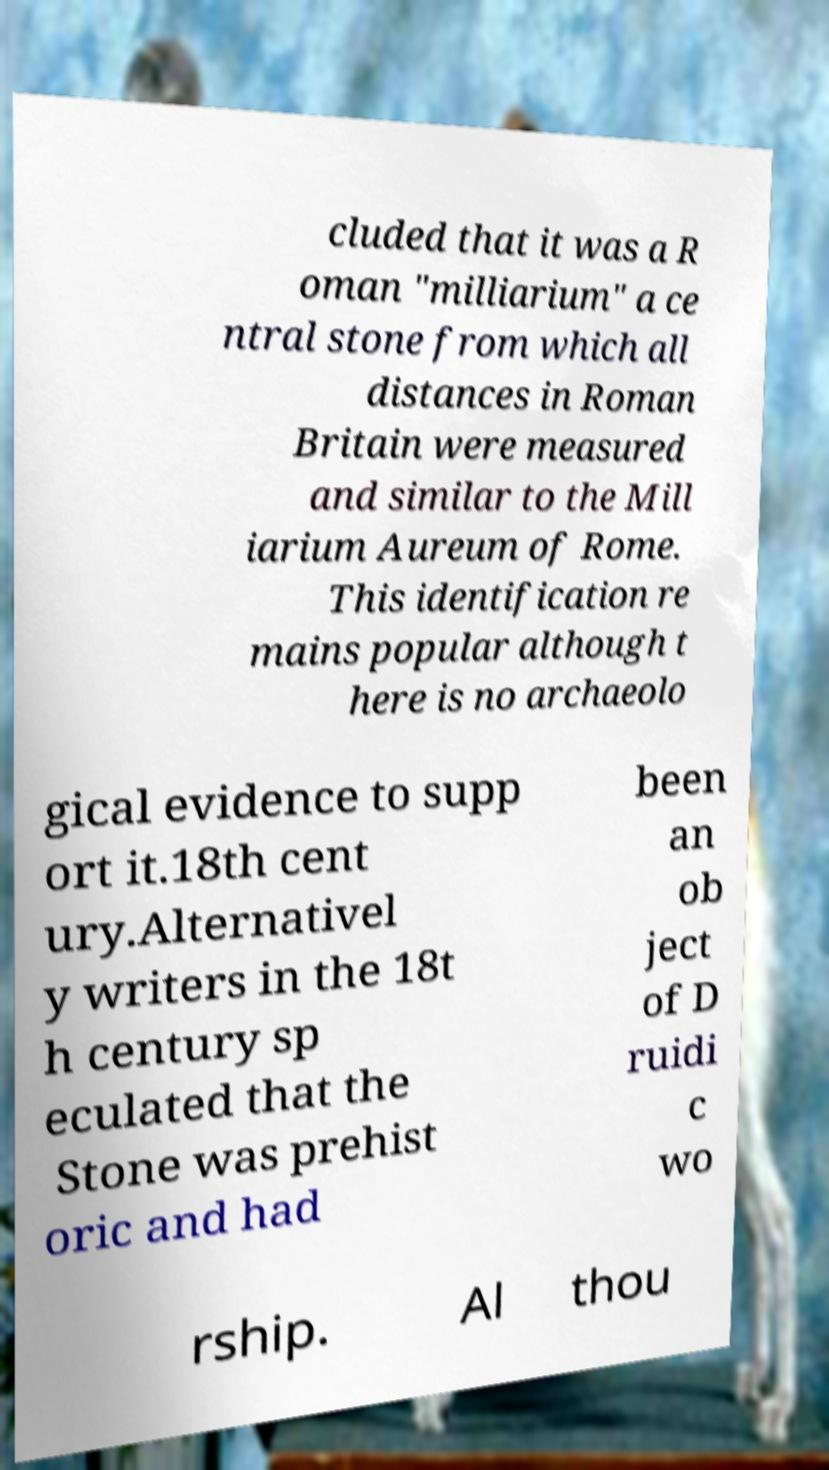Please read and relay the text visible in this image. What does it say? cluded that it was a R oman "milliarium" a ce ntral stone from which all distances in Roman Britain were measured and similar to the Mill iarium Aureum of Rome. This identification re mains popular although t here is no archaeolo gical evidence to supp ort it.18th cent ury.Alternativel y writers in the 18t h century sp eculated that the Stone was prehist oric and had been an ob ject of D ruidi c wo rship. Al thou 